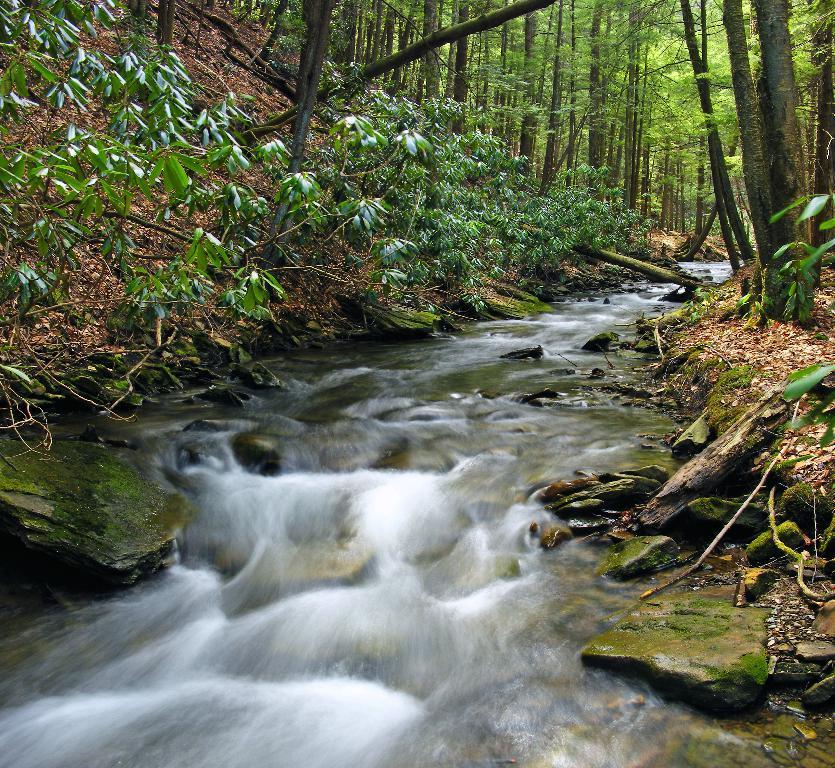How would you summarize this image in a sentence or two? In this image, we can see some water. We can see the ground with some dried leaves, plants. We can also see some trees and rocks. 